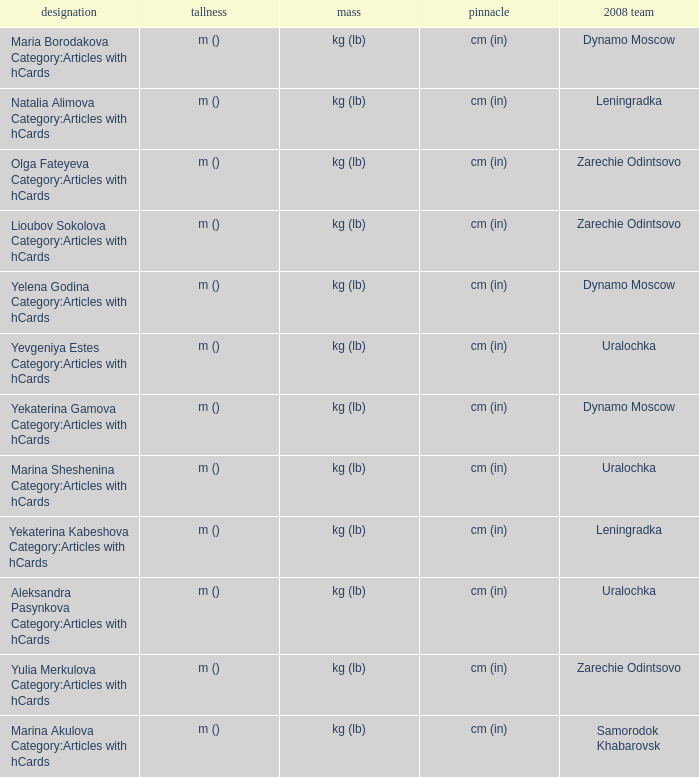What is the name when the 2008 club is uralochka? Yevgeniya Estes Category:Articles with hCards, Marina Sheshenina Category:Articles with hCards, Aleksandra Pasynkova Category:Articles with hCards. 